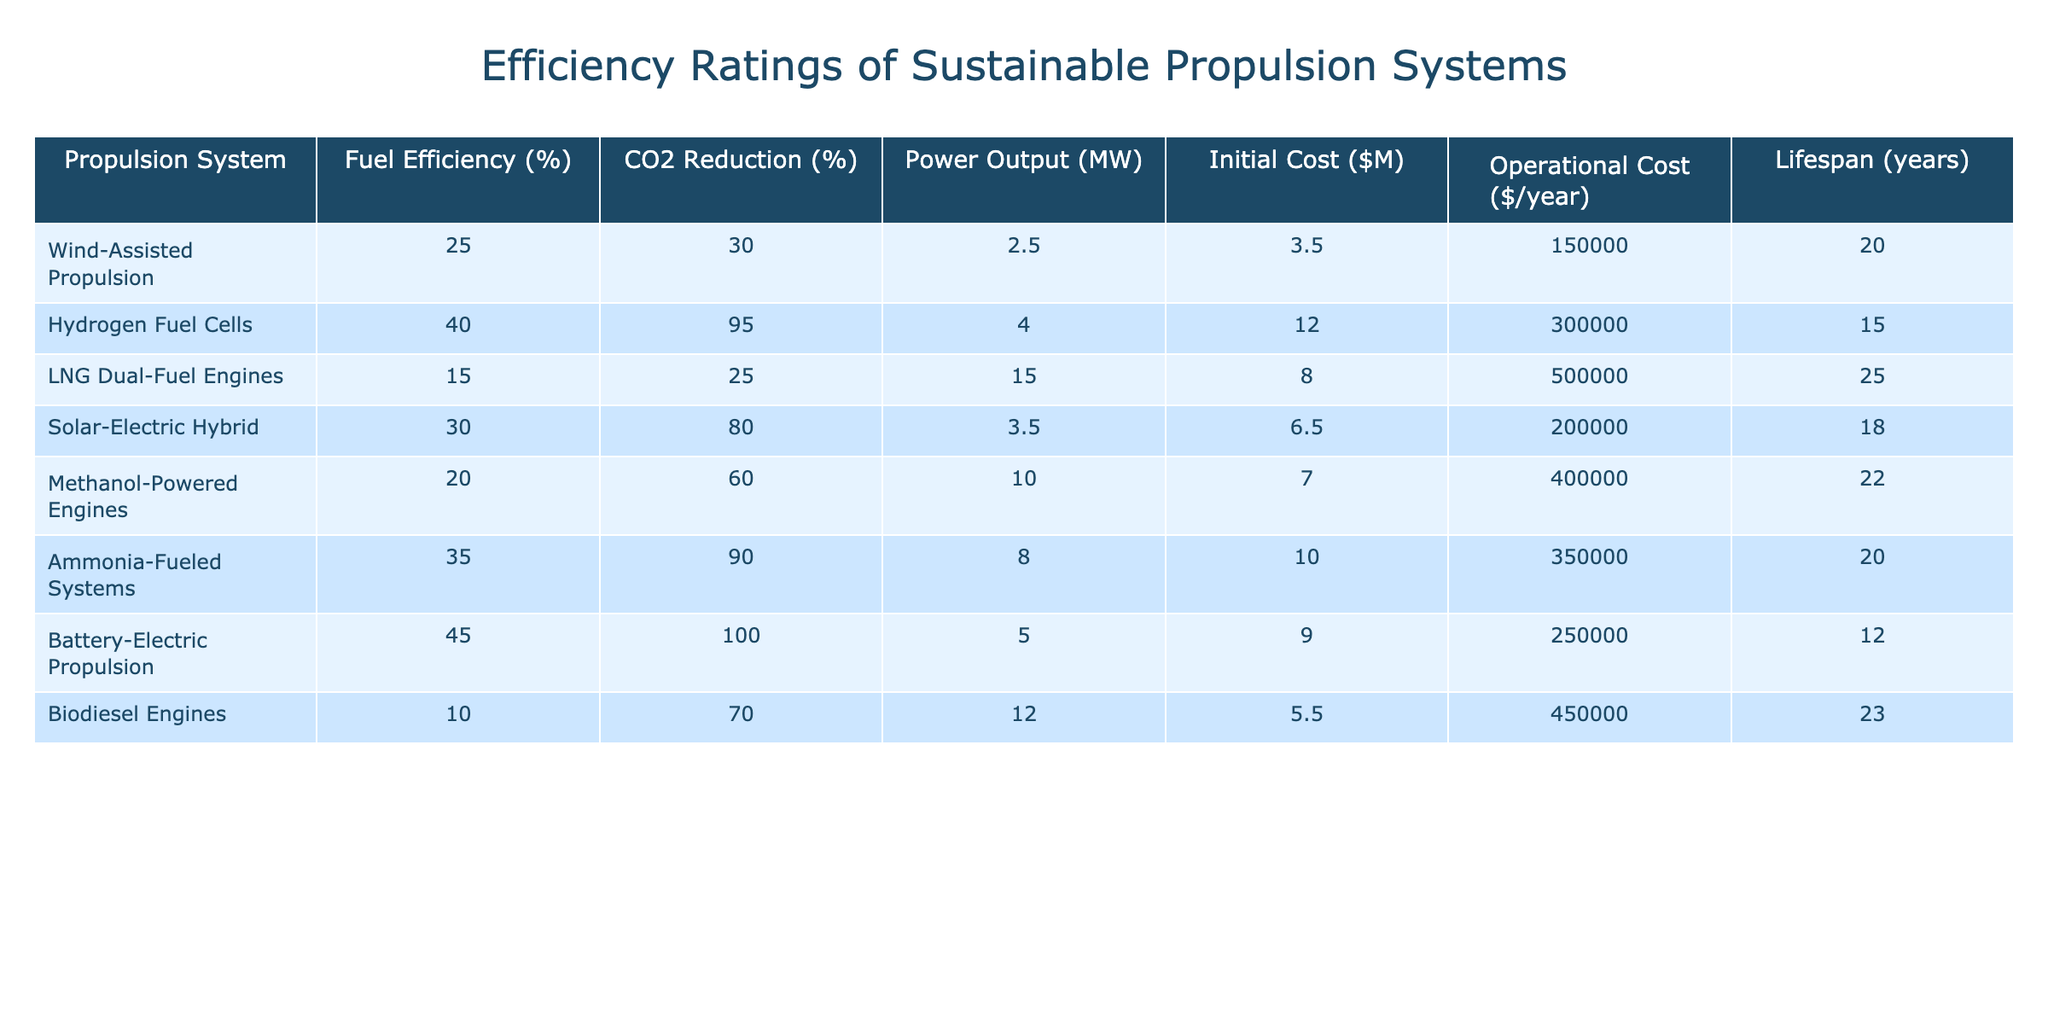What is the fuel efficiency of Battery-Electric Propulsion? The table shows that the fuel efficiency percentage for Battery-Electric Propulsion is listed as 45%.
Answer: 45% Which propulsion system has the highest CO2 reduction percentage? According to the table, Battery-Electric Propulsion has the highest CO2 reduction percentage at 100%.
Answer: 100% What is the average initial cost of the propulsion systems listed? To find the average, sum the initial costs: (3.5 + 12.0 + 8.0 + 6.5 + 7.0 + 10.0 + 9.0 + 5.5) = 57.5 and divide by 8: 57.5 / 8 = 7.1875, approximately $7.19M.
Answer: $7.19M Do any systems have a lifespan of 15 years or more? Yes, by checking the lifespan column, LNG Dual-Fuel Engines, Methanol-Powered Engines, Biodiesel Engines, and Ammonia-Fueled Systems all have lifespans of 15 years or more.
Answer: Yes Which propulsion system has the lowest operational cost, and what is that cost? The table indicates that the lowest operational cost is for Wind-Assisted Propulsion at $150,000 per year.
Answer: $150,000 If we compare Wind-Assisted Propulsion and Hydrogen Fuel Cells, which has a better fuel efficiency? Wind-Assisted Propulsion has a fuel efficiency of 25%, while Hydrogen Fuel Cells has 40%. Since 40% is greater than 25%, Hydrogen Fuel Cells has a better fuel efficiency.
Answer: Hydrogen Fuel Cells What is the total power output of all propulsion systems combined? Adding the power outputs: (2.5 + 4.0 + 15.0 + 3.5 + 10.0 + 8.0 + 5.0 + 12.0) results in a total of 60.0 MW.
Answer: 60.0 MW Which propulsion system incurs the highest operational cost? The table reveals that LNG Dual-Fuel Engines incurs the highest operational cost at $500,000 per year.
Answer: $500,000 Is there a propulsion system that has both over 30% fuel efficiency and CO2 reduction? Yes, examining the table, Hydrogen Fuel Cells (40% fuel efficiency and 95% CO2 reduction) and Battery-Electric Propulsion (45% fuel efficiency and 100% CO2 reduction) meet this criterion.
Answer: Yes What is the difference in lifespan between the Battery-Electric Propulsion and Hydrogen Fuel Cells? Battery-Electric Propulsion has a lifespan of 12 years and Hydrogen Fuel Cells has 15 years; the difference is 15 - 12 = 3 years.
Answer: 3 years 